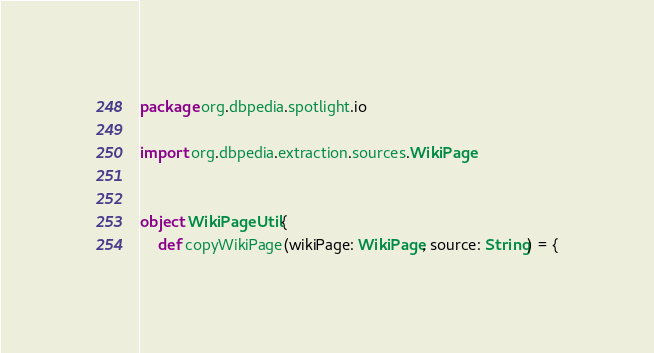<code> <loc_0><loc_0><loc_500><loc_500><_Scala_>package org.dbpedia.spotlight.io

import org.dbpedia.extraction.sources.WikiPage


object WikiPageUtil {
    def copyWikiPage(wikiPage: WikiPage, source: String) = {</code> 